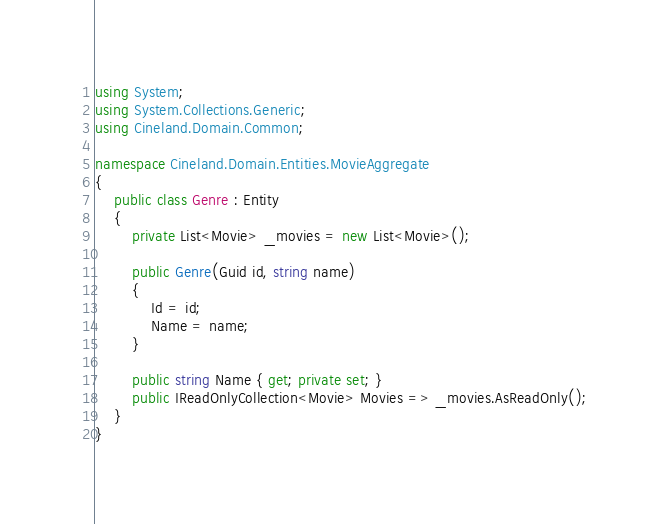Convert code to text. <code><loc_0><loc_0><loc_500><loc_500><_C#_>using System;
using System.Collections.Generic;
using Cineland.Domain.Common;

namespace Cineland.Domain.Entities.MovieAggregate
{
    public class Genre : Entity
    {
        private List<Movie> _movies = new List<Movie>();

        public Genre(Guid id, string name)
        {
            Id = id;
            Name = name;
        }

        public string Name { get; private set; }
        public IReadOnlyCollection<Movie> Movies => _movies.AsReadOnly();
    }
}</code> 